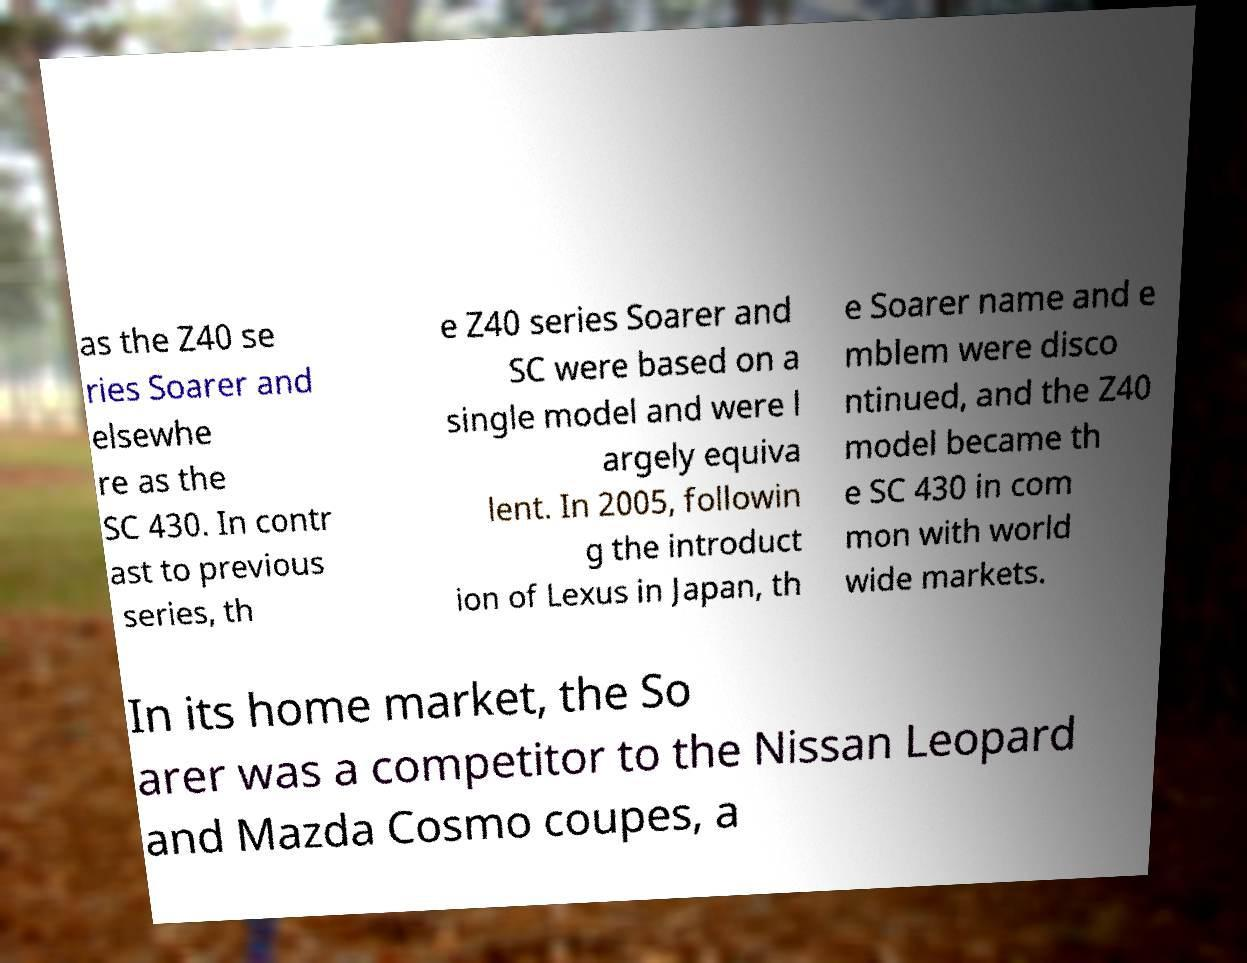There's text embedded in this image that I need extracted. Can you transcribe it verbatim? as the Z40 se ries Soarer and elsewhe re as the SC 430. In contr ast to previous series, th e Z40 series Soarer and SC were based on a single model and were l argely equiva lent. In 2005, followin g the introduct ion of Lexus in Japan, th e Soarer name and e mblem were disco ntinued, and the Z40 model became th e SC 430 in com mon with world wide markets. In its home market, the So arer was a competitor to the Nissan Leopard and Mazda Cosmo coupes, a 